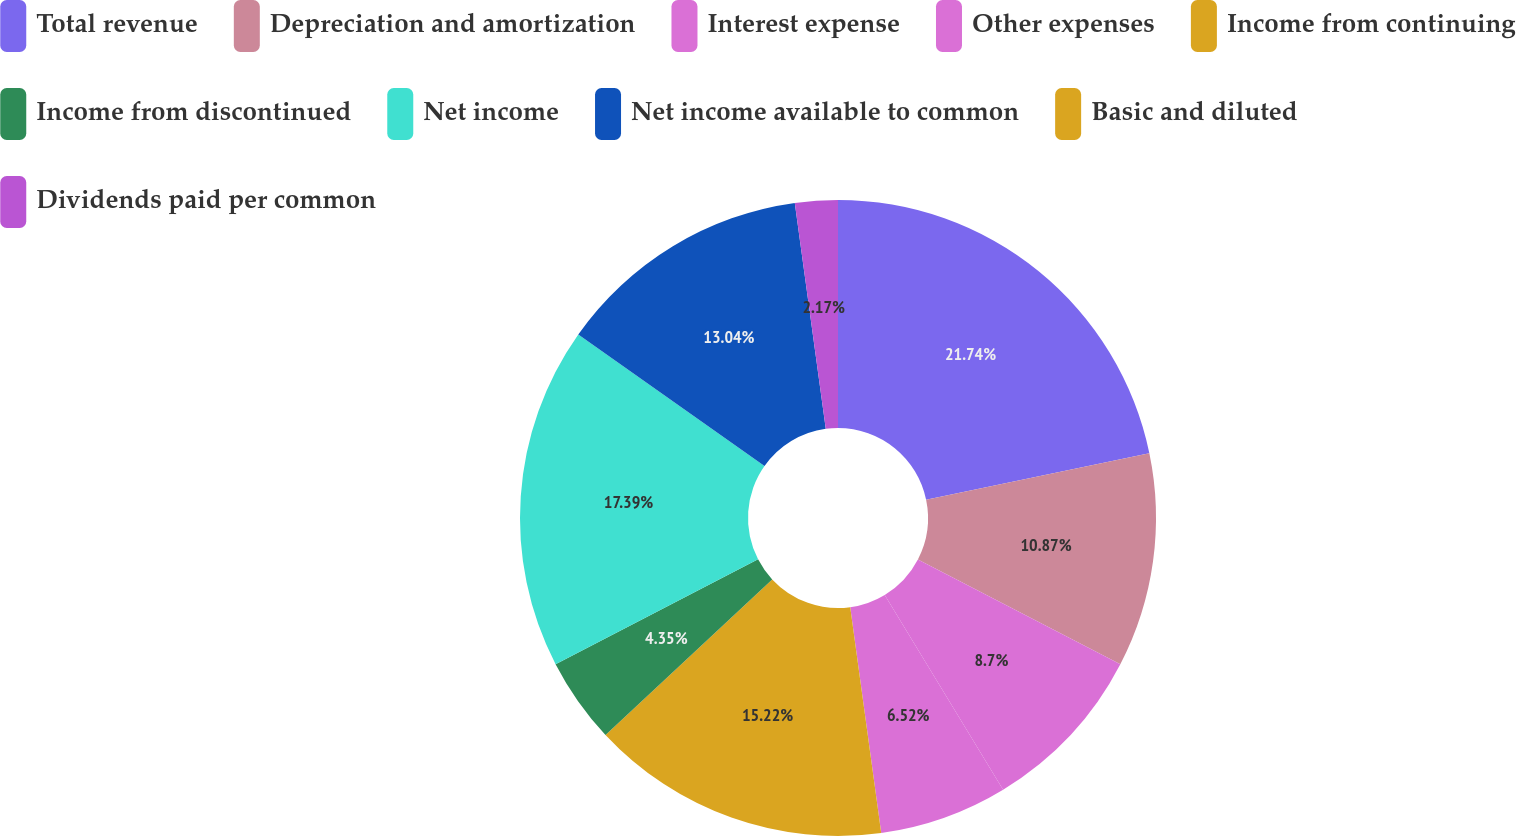<chart> <loc_0><loc_0><loc_500><loc_500><pie_chart><fcel>Total revenue<fcel>Depreciation and amortization<fcel>Interest expense<fcel>Other expenses<fcel>Income from continuing<fcel>Income from discontinued<fcel>Net income<fcel>Net income available to common<fcel>Basic and diluted<fcel>Dividends paid per common<nl><fcel>21.74%<fcel>10.87%<fcel>8.7%<fcel>6.52%<fcel>15.22%<fcel>4.35%<fcel>17.39%<fcel>13.04%<fcel>0.0%<fcel>2.17%<nl></chart> 